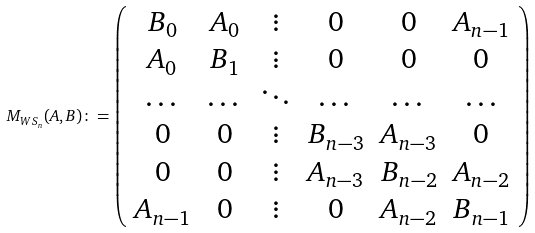Convert formula to latex. <formula><loc_0><loc_0><loc_500><loc_500>M _ { W S _ { n } } ( A , B ) \colon = \left ( \begin{array} { c c c c c c } B _ { 0 } & A _ { 0 } & \vdots & 0 & 0 & A _ { n - 1 } \\ A _ { 0 } & B _ { 1 } & \vdots & 0 & 0 & 0 \\ \dots & \dots & \ddots & \dots & \dots & \dots \\ 0 & 0 & \vdots & B _ { n - 3 } & A _ { n - 3 } & 0 \\ 0 & 0 & \vdots & A _ { n - 3 } & B _ { n - 2 } & A _ { n - 2 } \\ A _ { n - 1 } & 0 & \vdots & 0 & A _ { n - 2 } & B _ { n - 1 } \\ \end{array} \right )</formula> 